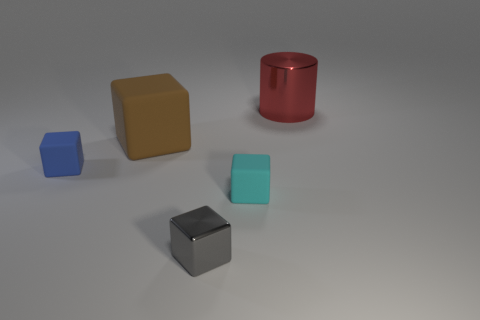What number of purple objects are things or small spheres?
Give a very brief answer. 0. What number of other objects are the same shape as the large matte thing?
Give a very brief answer. 3. Is the cyan thing made of the same material as the big brown cube?
Provide a short and direct response. Yes. The small cube that is both to the right of the tiny blue thing and on the left side of the tiny cyan rubber thing is made of what material?
Your response must be concise. Metal. The metal thing in front of the cylinder is what color?
Give a very brief answer. Gray. Is the number of cyan cubes on the right side of the blue thing greater than the number of purple rubber cubes?
Your answer should be compact. Yes. How many other objects are there of the same size as the blue rubber thing?
Provide a short and direct response. 2. What number of tiny gray cubes are on the right side of the big red shiny object?
Your answer should be very brief. 0. Are there the same number of big shiny things that are on the right side of the tiny blue block and blue rubber cubes on the left side of the big red metallic thing?
Offer a terse response. Yes. What is the size of the metallic object that is the same shape as the blue matte thing?
Provide a succinct answer. Small. 